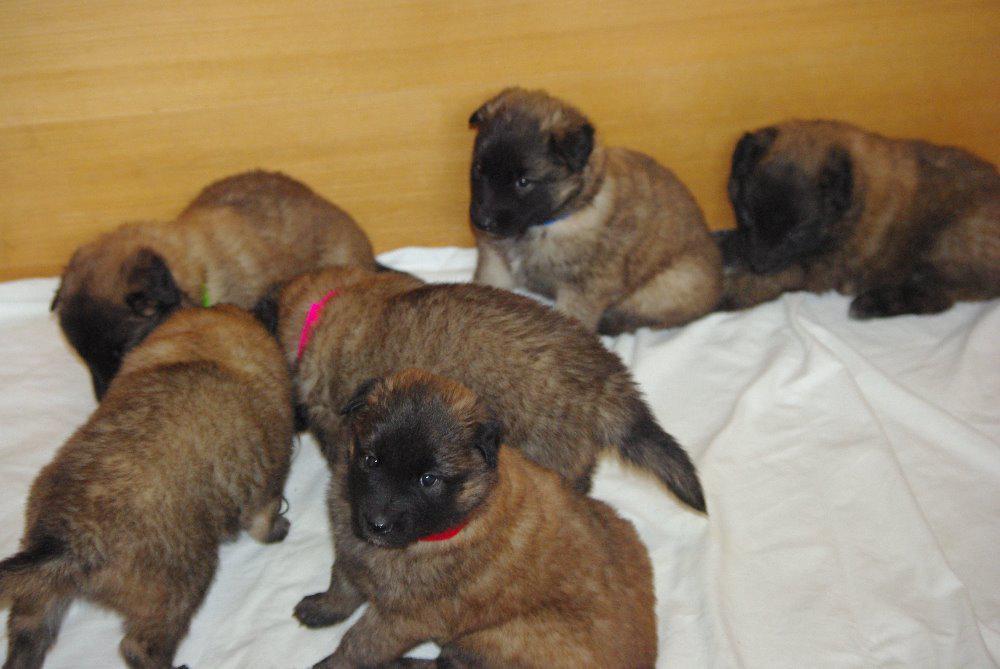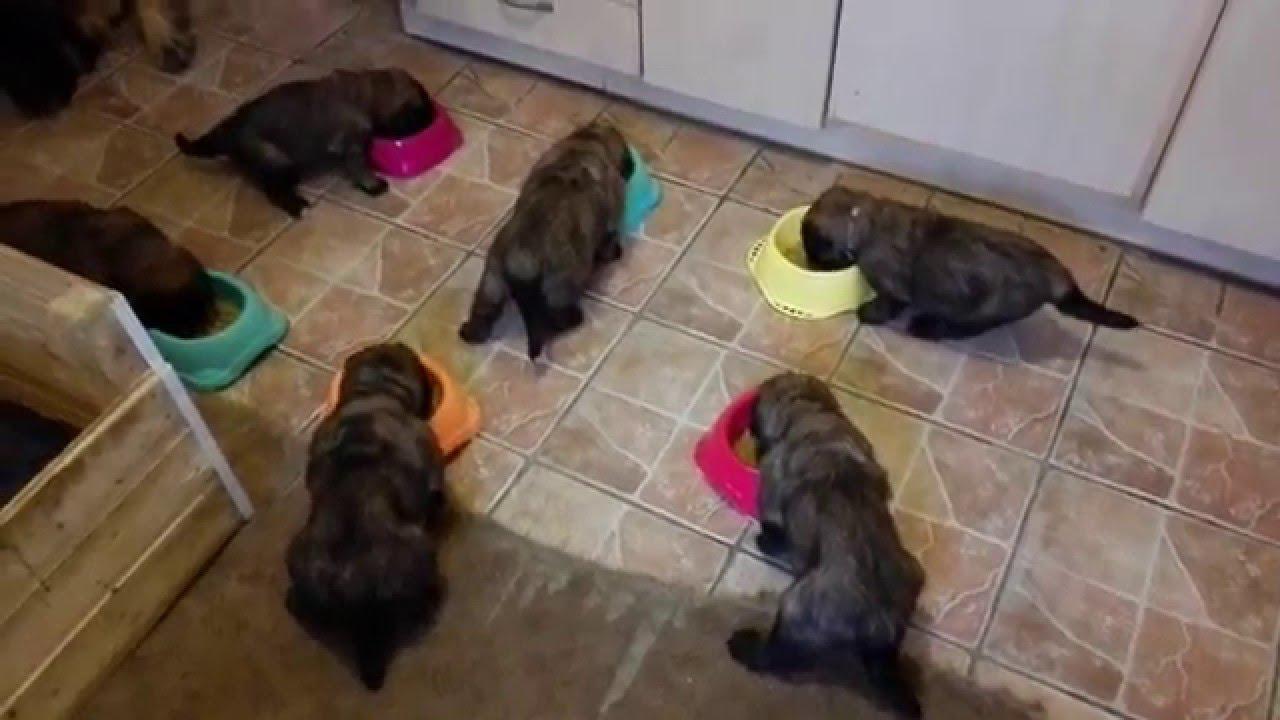The first image is the image on the left, the second image is the image on the right. Considering the images on both sides, is "An image shows at least one puppy on a stone-type floor with a pattern that includes square shapes." valid? Answer yes or no. Yes. The first image is the image on the left, the second image is the image on the right. Evaluate the accuracy of this statement regarding the images: "A single dog is standing on a white surface in one of the images.". Is it true? Answer yes or no. No. 